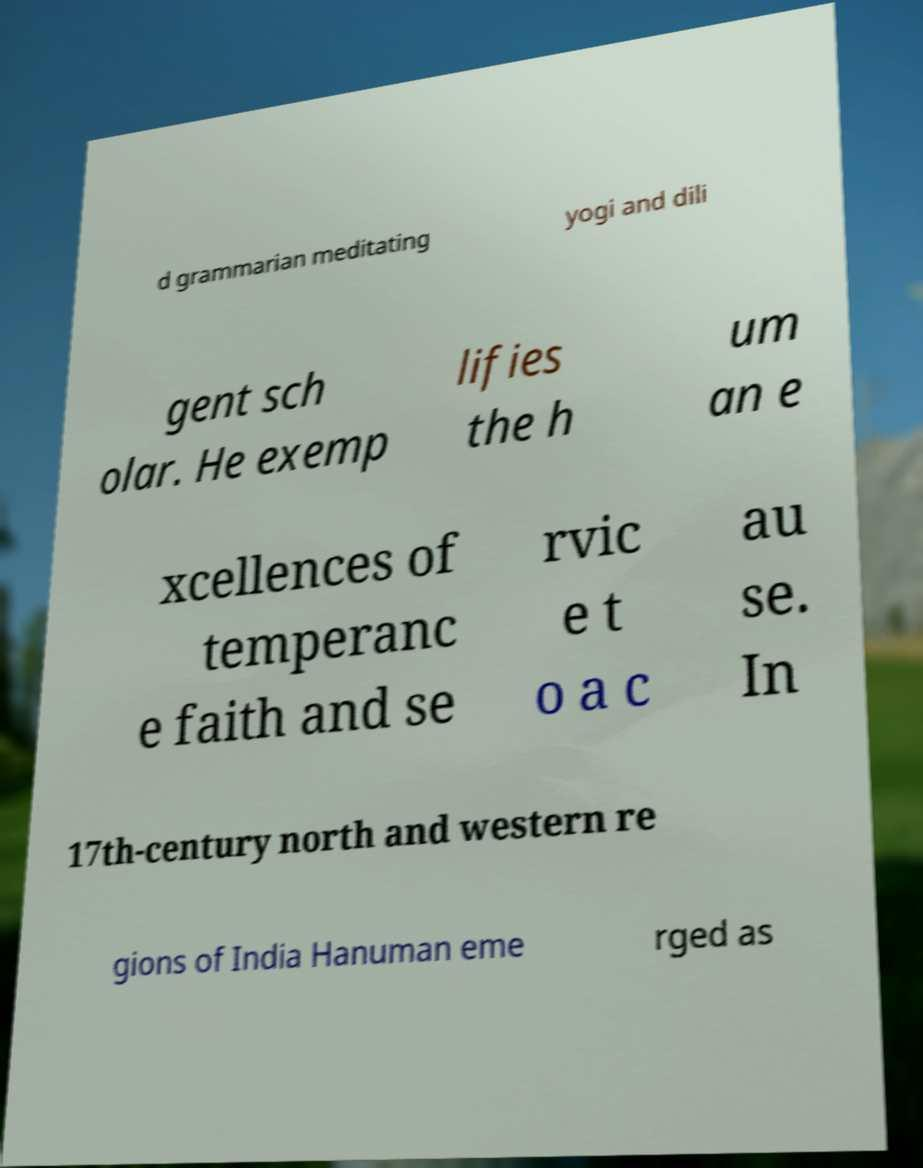What messages or text are displayed in this image? I need them in a readable, typed format. d grammarian meditating yogi and dili gent sch olar. He exemp lifies the h um an e xcellences of temperanc e faith and se rvic e t o a c au se. In 17th-century north and western re gions of India Hanuman eme rged as 